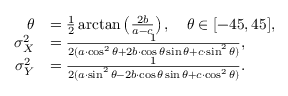<formula> <loc_0><loc_0><loc_500><loc_500>{ \begin{array} { r l } { \theta } & { = { \frac { 1 } { 2 } } \arctan \left ( { \frac { 2 b } { a - c } } \right ) , \quad \theta \in [ - 4 5 , 4 5 ] , } \\ { \sigma _ { X } ^ { 2 } } & { = { \frac { 1 } { 2 ( a \cdot \cos ^ { 2 } \theta + 2 b \cdot \cos \theta \sin \theta + c \cdot \sin ^ { 2 } \theta ) } } , } \\ { \sigma _ { Y } ^ { 2 } } & { = { \frac { 1 } { 2 ( a \cdot \sin ^ { 2 } \theta - 2 b \cdot \cos \theta \sin \theta + c \cdot \cos ^ { 2 } \theta ) } } . } \end{array} }</formula> 